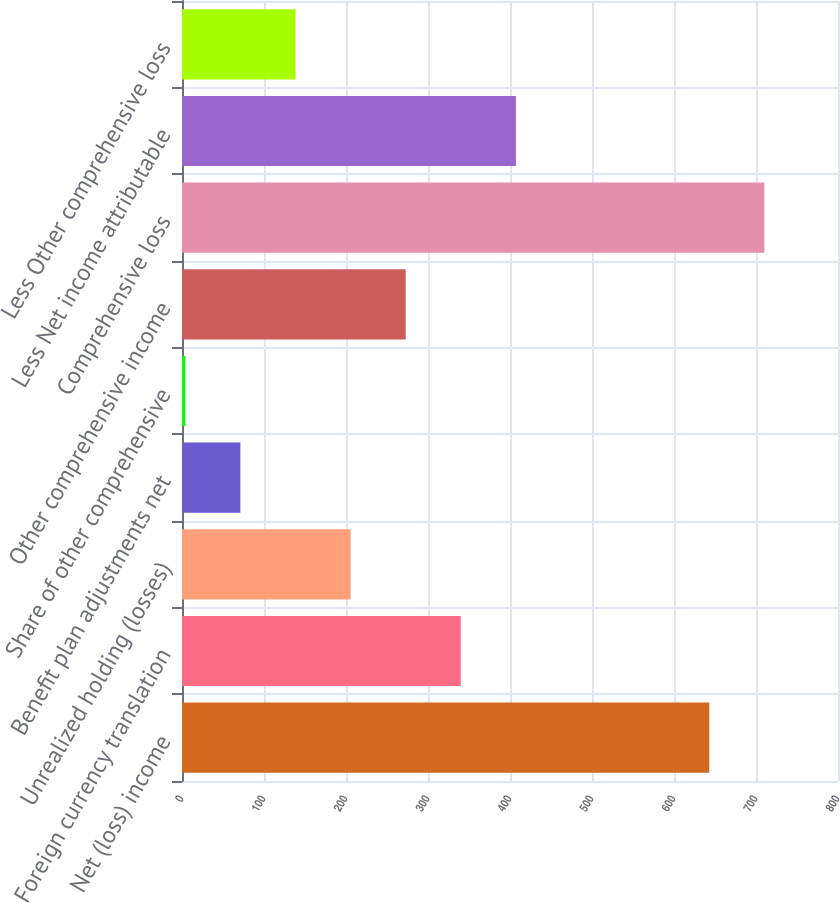<chart> <loc_0><loc_0><loc_500><loc_500><bar_chart><fcel>Net (loss) income<fcel>Foreign currency translation<fcel>Unrealized holding (losses)<fcel>Benefit plan adjustments net<fcel>Share of other comprehensive<fcel>Other comprehensive income<fcel>Comprehensive loss<fcel>Less Net income attributable<fcel>Less Other comprehensive loss<nl><fcel>643<fcel>340<fcel>205.6<fcel>71.2<fcel>4<fcel>272.8<fcel>710.2<fcel>407.2<fcel>138.4<nl></chart> 